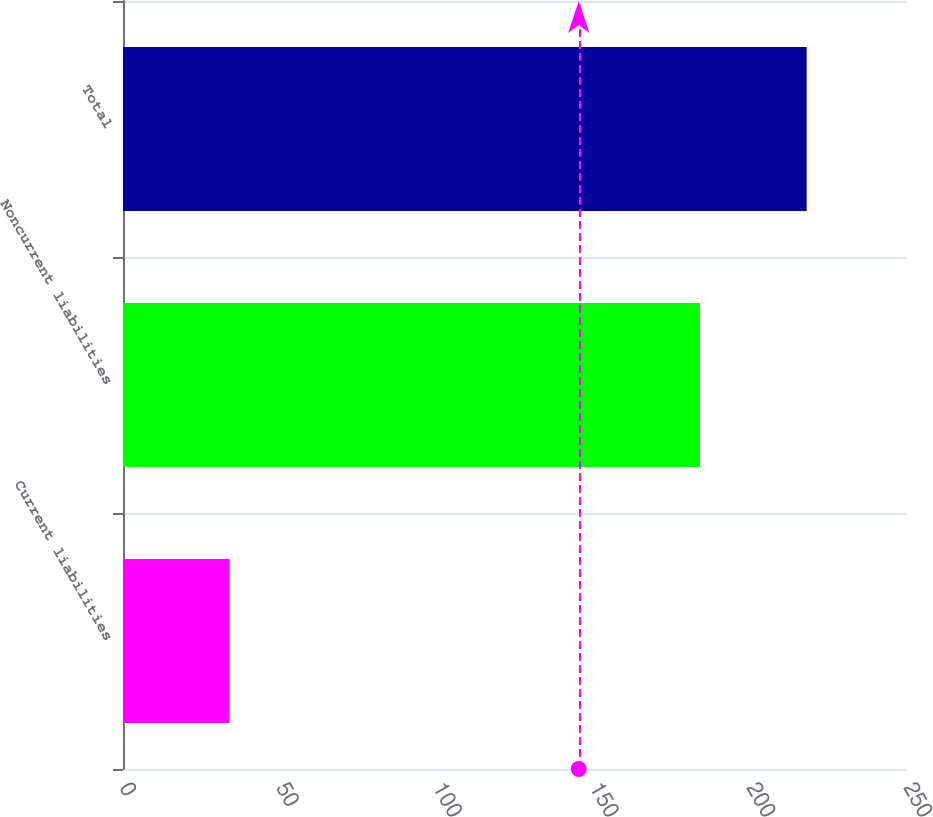Convert chart. <chart><loc_0><loc_0><loc_500><loc_500><bar_chart><fcel>Current liabilities<fcel>Noncurrent liabilities<fcel>Total<nl><fcel>34<fcel>184<fcel>218<nl></chart> 